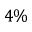Convert formula to latex. <formula><loc_0><loc_0><loc_500><loc_500>4 \%</formula> 